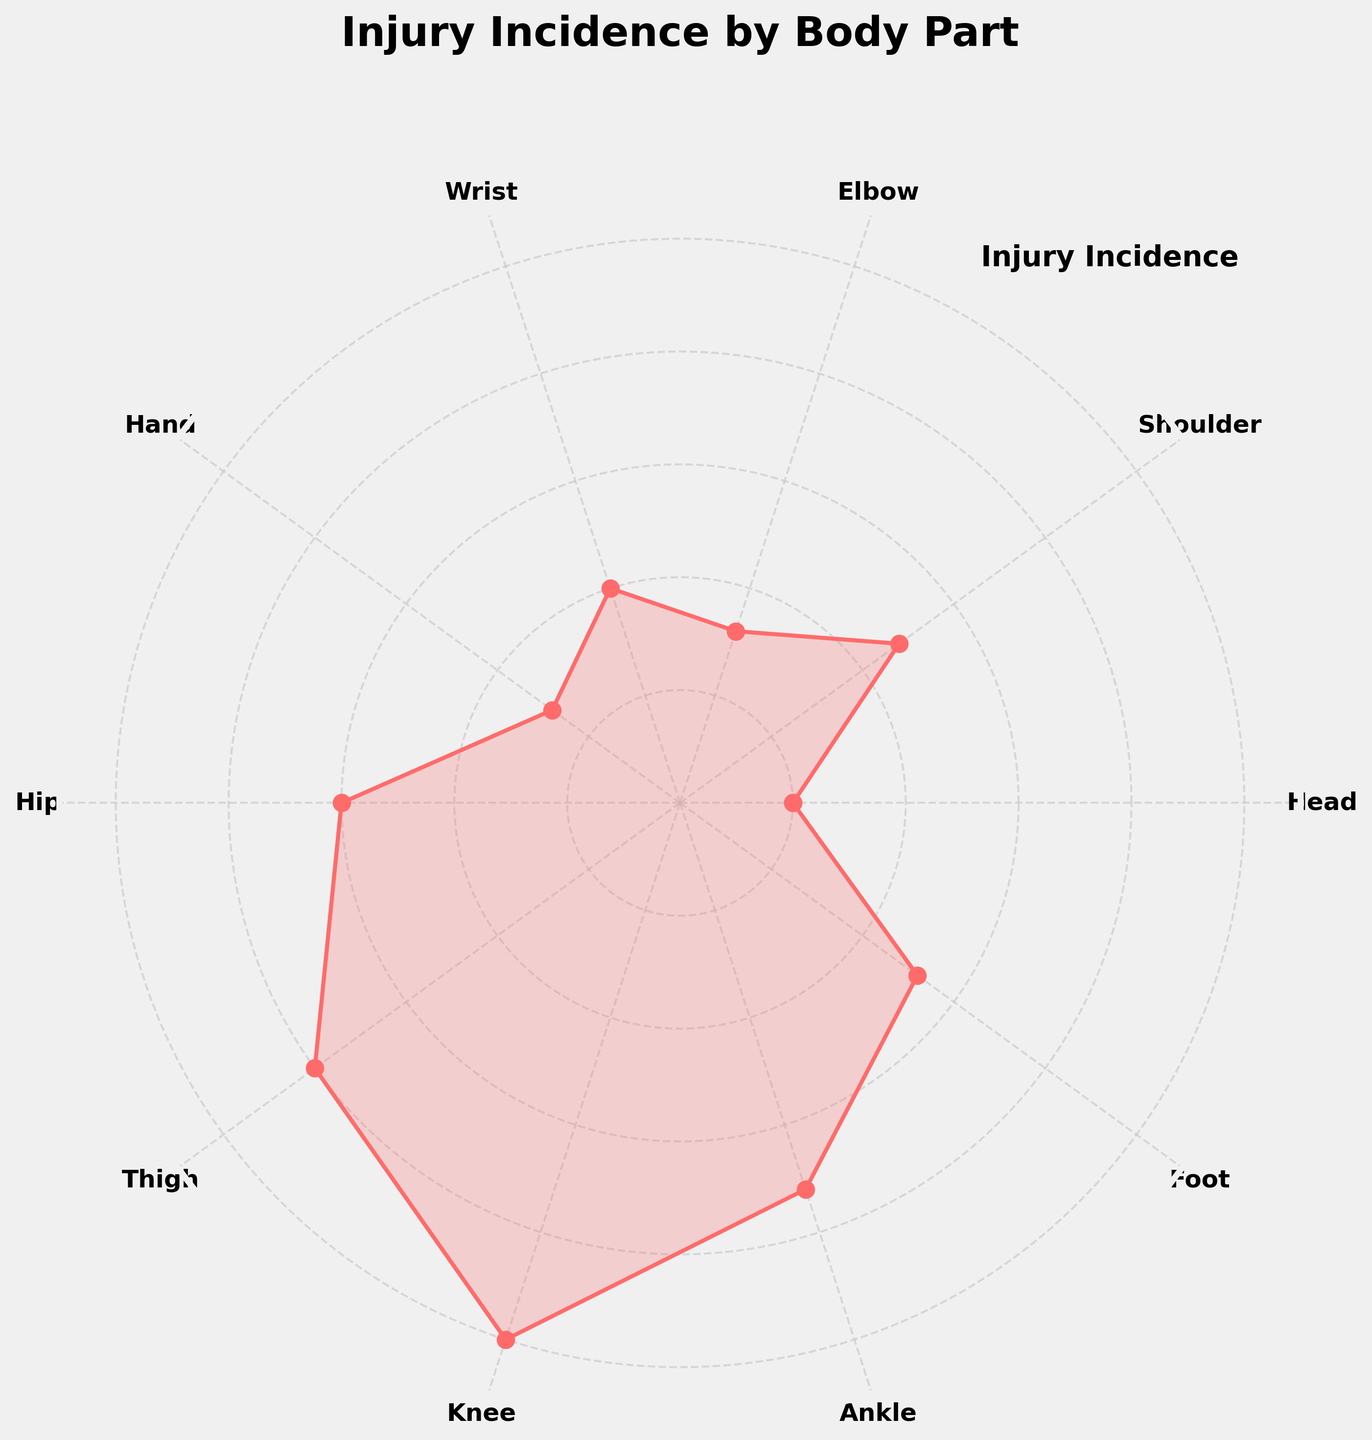What is the title of the chart? The large, bold text at the top of the chart indicates the title.
Answer: Injury Incidence by Body Part Which body part has the highest injury incidence? The data point farthest from the center of the polar chart represents the highest value.
Answer: Knee How many body parts have an injury incidence above 20? Count the data points that are positioned beyond the 20-mark radius on the polar chart.
Answer: 1 Which body part has fewer injuries, the shoulder or the wrist? Compare the positions of the respective data points on the chart relative to the center.
Answer: Wrist What is the average injury incidence of the knee and ankle? Sum the incidence values of knee (25) and ankle (18) and divide by 2. (25 + 18) / 2 = 21.5
Answer: 21.5 Does the hip have a higher or lower injury incidence than the foot? Compare the positions of the data points labeled "Hip" and "Foot" on the polar chart.
Answer: Higher Which body parts have an injury incidence of less than 10? Identify the data points that are positioned within the radius marked 10 on the chart.
Answer: Head, Hand What is the difference in injury incidence between the thigh and the elbow? Subtract the incidence value of the elbow (8) from that of the thigh (20). 20 - 8 = 12
Answer: 12 How does the injury incidence of the elbow compare to the wrist? Compare the positions of the respective data points on the chart relative to the center.
Answer: Lower What is the total sum of injury incidences for the head, shoulder, and hand? Add the incidence values for the head (5), shoulder (12), and hand (7). (5 + 12 + 7) = 24
Answer: 24 